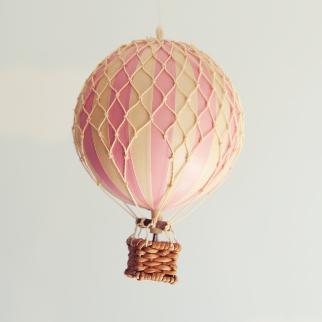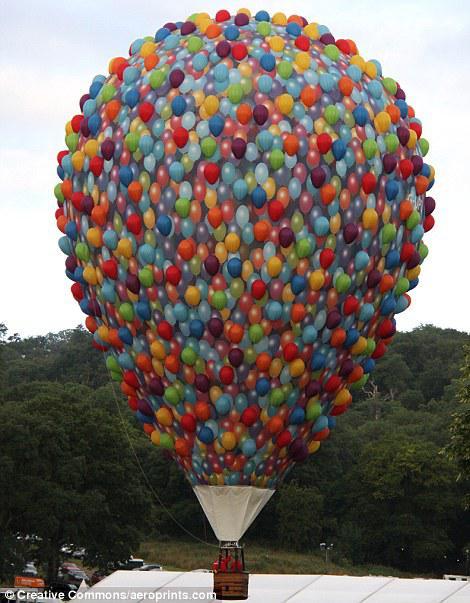The first image is the image on the left, the second image is the image on the right. Considering the images on both sides, is "Only one image shows a hot air balloon made of many balloons." valid? Answer yes or no. Yes. 